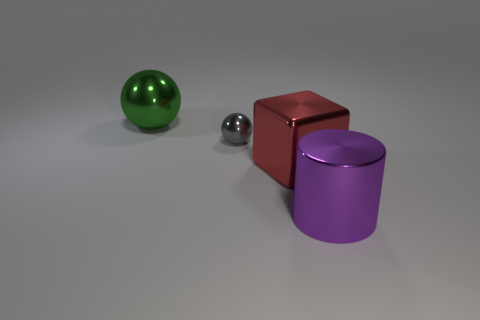Do the gray object and the big green metallic object have the same shape?
Offer a very short reply. Yes. What is the material of the thing that is to the right of the big green sphere and on the left side of the large red object?
Provide a short and direct response. Metal. What is the size of the metallic cube?
Provide a short and direct response. Large. What color is the other big metallic thing that is the same shape as the gray thing?
Offer a very short reply. Green. Is the size of the thing that is to the right of the red block the same as the gray metallic ball that is behind the big red shiny cube?
Offer a very short reply. No. Is the number of red blocks left of the small metal sphere the same as the number of shiny things in front of the red block?
Your response must be concise. No. There is a green object; is it the same size as the sphere in front of the big sphere?
Offer a very short reply. No. Is there a metallic object that is in front of the metallic object that is on the left side of the small metal object?
Provide a short and direct response. Yes. Is there another purple metal object of the same shape as the large purple shiny thing?
Ensure brevity in your answer.  No. There is a shiny ball that is to the right of the sphere to the left of the gray shiny ball; how many big green balls are right of it?
Your answer should be very brief. 0. 